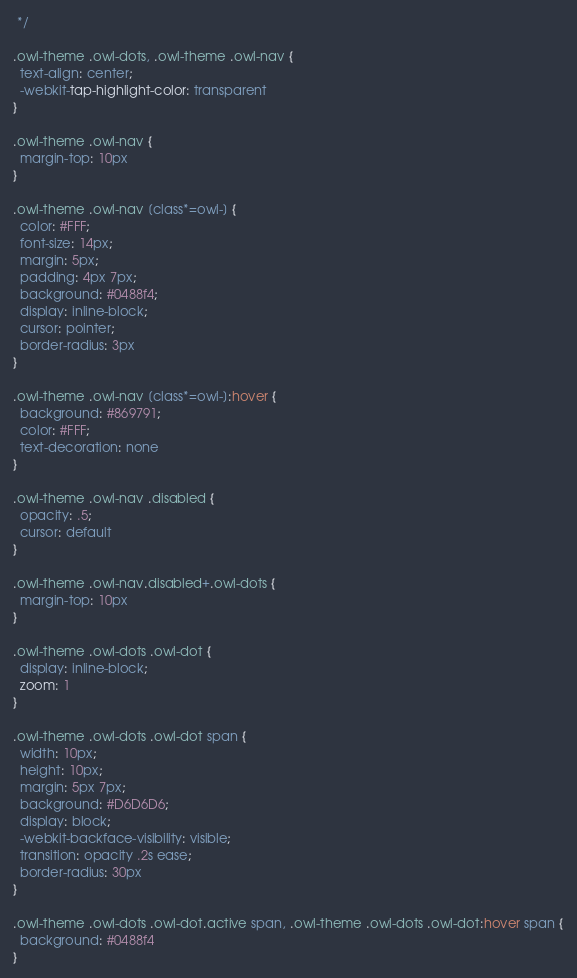<code> <loc_0><loc_0><loc_500><loc_500><_CSS_> */

.owl-theme .owl-dots, .owl-theme .owl-nav {
  text-align: center;
  -webkit-tap-highlight-color: transparent
}

.owl-theme .owl-nav {
  margin-top: 10px
}

.owl-theme .owl-nav [class*=owl-] {
  color: #FFF;
  font-size: 14px;
  margin: 5px;
  padding: 4px 7px;
  background: #0488f4;
  display: inline-block;
  cursor: pointer;
  border-radius: 3px
}

.owl-theme .owl-nav [class*=owl-]:hover {
  background: #869791;
  color: #FFF;
  text-decoration: none
}

.owl-theme .owl-nav .disabled {
  opacity: .5;
  cursor: default
}

.owl-theme .owl-nav.disabled+.owl-dots {
  margin-top: 10px
}

.owl-theme .owl-dots .owl-dot {
  display: inline-block;
  zoom: 1
}

.owl-theme .owl-dots .owl-dot span {
  width: 10px;
  height: 10px;
  margin: 5px 7px;
  background: #D6D6D6;
  display: block;
  -webkit-backface-visibility: visible;
  transition: opacity .2s ease;
  border-radius: 30px
}

.owl-theme .owl-dots .owl-dot.active span, .owl-theme .owl-dots .owl-dot:hover span {
  background: #0488f4
}
</code> 